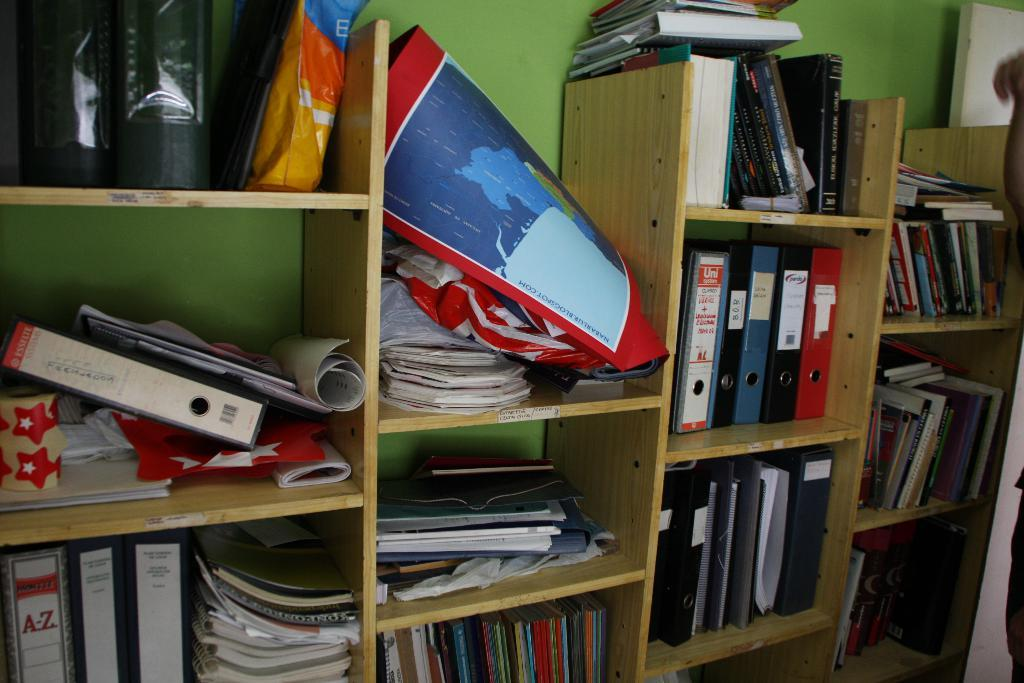<image>
Share a concise interpretation of the image provided. Shelf that has a book which says A-Z. 